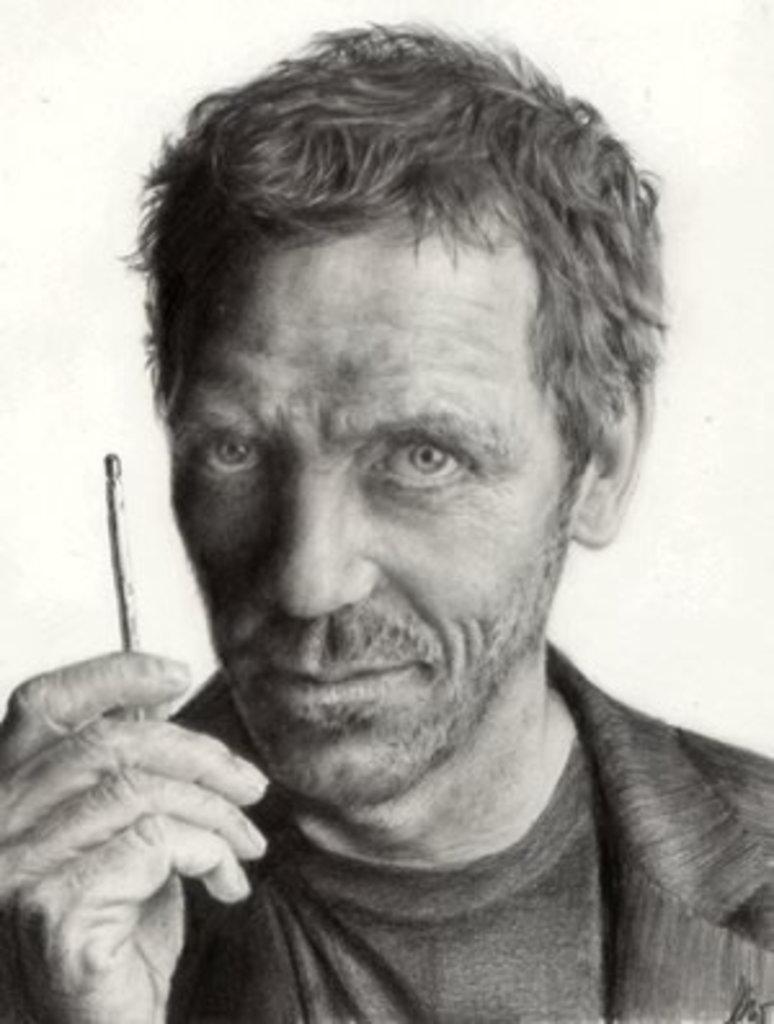Describe this image in one or two sentences. In the picture there is a man holding an object with the hand. 